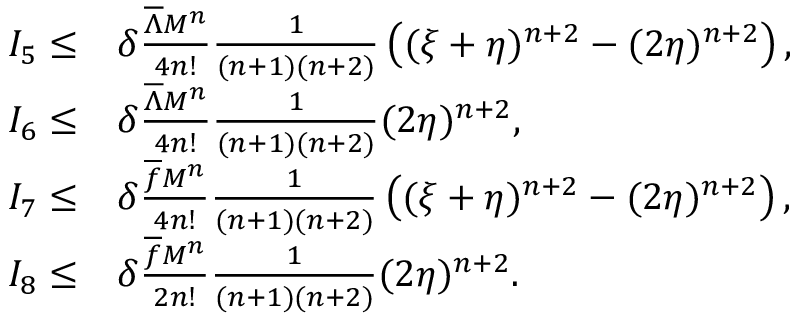Convert formula to latex. <formula><loc_0><loc_0><loc_500><loc_500>\begin{array} { r l } { I _ { 5 } \leq } & { \delta \frac { { { \overline { \Lambda } } } M ^ { n } } { 4 n ! } \frac { 1 } { ( n + 1 ) ( n + 2 ) } \left ( ( \xi + \eta ) ^ { n + 2 } - ( 2 \eta ) ^ { n + 2 } \right ) , } \\ { I _ { 6 } \leq } & { \delta \frac { { { \overline { \Lambda } } } M ^ { n } } { 4 n ! } \frac { 1 } { ( n + 1 ) ( n + 2 ) } ( 2 \eta ) ^ { n + 2 } , } \\ { I _ { 7 } \leq } & { \delta \frac { \overline { f } M ^ { n } } { 4 n ! } \frac { 1 } { ( n + 1 ) ( n + 2 ) } \left ( ( \xi + \eta ) ^ { n + 2 } - ( 2 \eta ) ^ { n + 2 } \right ) , } \\ { I _ { 8 } \leq } & { \delta \frac { \overline { f } M ^ { n } } { 2 n ! } \frac { 1 } { ( n + 1 ) ( n + 2 ) } ( 2 \eta ) ^ { n + 2 } . } \end{array}</formula> 